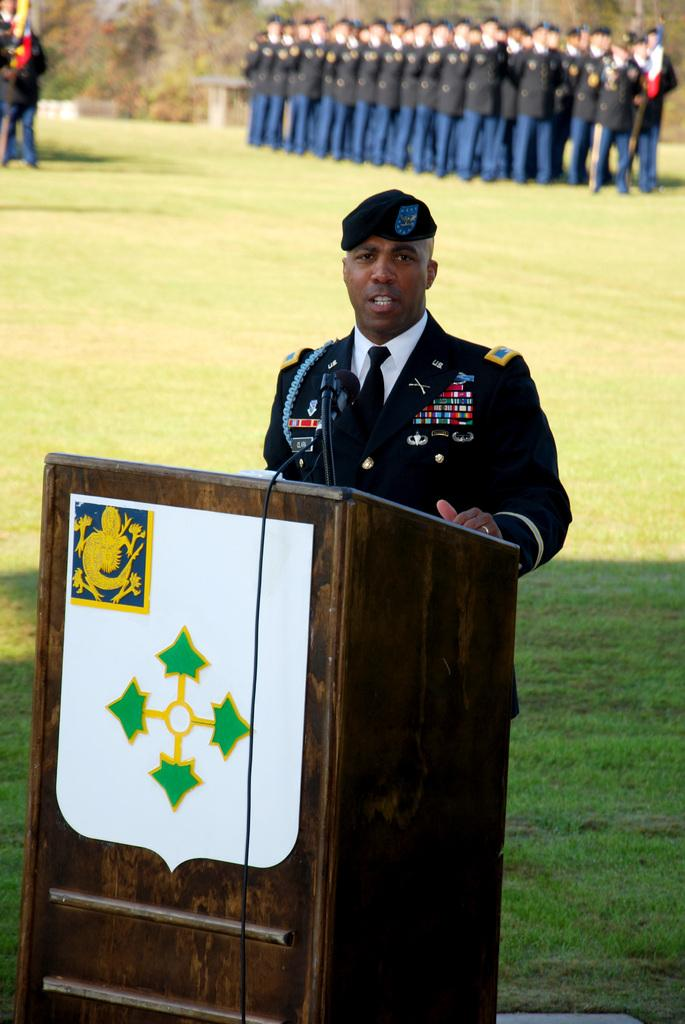What is the main subject of the image? There is a man standing in the image. What object is near the man in the image? There is a wooden podium with a microphone in the image. What can be seen in the background of the image? There is a group of people standing in the background of the image. What type of ground surface is visible in the image? There is grass visible in the image. What type of dinosaurs can be seen grazing on the grass in the image? There are no dinosaurs present in the image; it features a man standing near a wooden podium with a microphone, a group of people in the background, and grass. What type of metal is used to construct the microphone in the image? The type of metal used to construct the microphone cannot be determined from the image. 